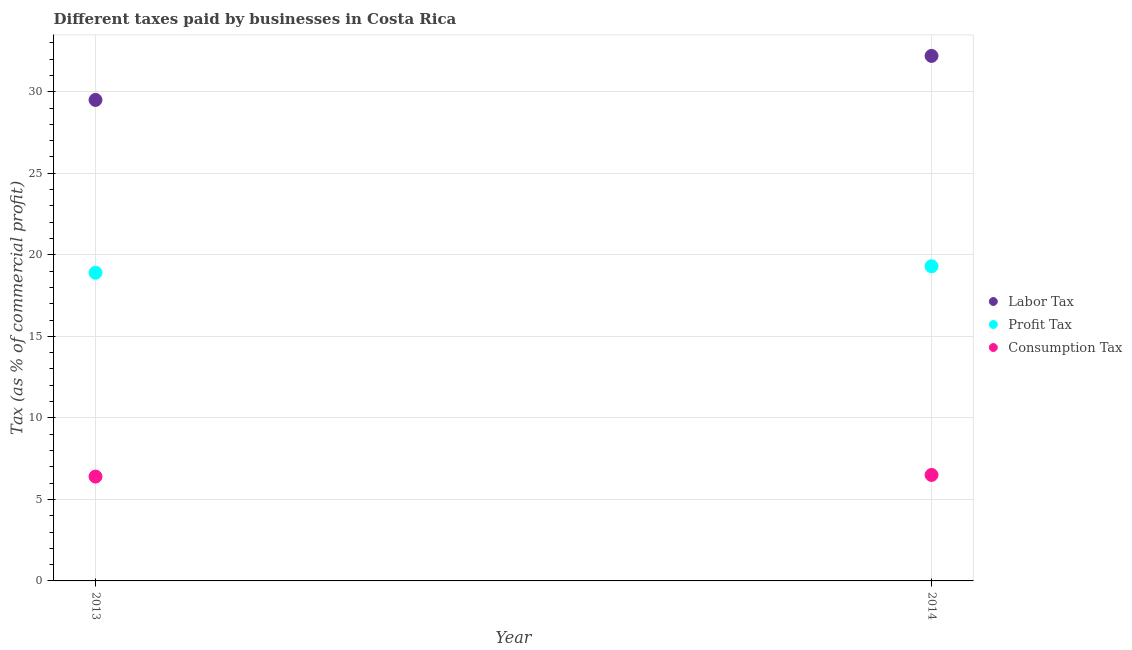How many different coloured dotlines are there?
Provide a short and direct response. 3. Is the number of dotlines equal to the number of legend labels?
Give a very brief answer. Yes. What is the percentage of consumption tax in 2013?
Keep it short and to the point. 6.4. Across all years, what is the maximum percentage of consumption tax?
Your answer should be very brief. 6.5. Across all years, what is the minimum percentage of labor tax?
Offer a terse response. 29.5. In which year was the percentage of consumption tax maximum?
Offer a terse response. 2014. In which year was the percentage of labor tax minimum?
Your response must be concise. 2013. What is the total percentage of consumption tax in the graph?
Make the answer very short. 12.9. What is the difference between the percentage of consumption tax in 2013 and that in 2014?
Provide a succinct answer. -0.1. What is the difference between the percentage of labor tax in 2014 and the percentage of consumption tax in 2013?
Provide a succinct answer. 25.8. What is the average percentage of labor tax per year?
Keep it short and to the point. 30.85. In the year 2013, what is the difference between the percentage of profit tax and percentage of labor tax?
Ensure brevity in your answer.  -10.6. In how many years, is the percentage of labor tax greater than 30 %?
Provide a succinct answer. 1. What is the ratio of the percentage of labor tax in 2013 to that in 2014?
Keep it short and to the point. 0.92. Is the percentage of consumption tax in 2013 less than that in 2014?
Your response must be concise. Yes. In how many years, is the percentage of consumption tax greater than the average percentage of consumption tax taken over all years?
Provide a short and direct response. 1. Is the percentage of consumption tax strictly greater than the percentage of profit tax over the years?
Your answer should be compact. No. Is the percentage of labor tax strictly less than the percentage of consumption tax over the years?
Provide a short and direct response. No. What is the difference between two consecutive major ticks on the Y-axis?
Keep it short and to the point. 5. Are the values on the major ticks of Y-axis written in scientific E-notation?
Offer a very short reply. No. Does the graph contain grids?
Offer a terse response. Yes. How many legend labels are there?
Make the answer very short. 3. How are the legend labels stacked?
Provide a succinct answer. Vertical. What is the title of the graph?
Offer a very short reply. Different taxes paid by businesses in Costa Rica. What is the label or title of the X-axis?
Offer a very short reply. Year. What is the label or title of the Y-axis?
Your answer should be compact. Tax (as % of commercial profit). What is the Tax (as % of commercial profit) in Labor Tax in 2013?
Your response must be concise. 29.5. What is the Tax (as % of commercial profit) of Labor Tax in 2014?
Provide a short and direct response. 32.2. What is the Tax (as % of commercial profit) of Profit Tax in 2014?
Offer a terse response. 19.3. Across all years, what is the maximum Tax (as % of commercial profit) of Labor Tax?
Offer a very short reply. 32.2. Across all years, what is the maximum Tax (as % of commercial profit) of Profit Tax?
Provide a short and direct response. 19.3. Across all years, what is the maximum Tax (as % of commercial profit) in Consumption Tax?
Provide a succinct answer. 6.5. Across all years, what is the minimum Tax (as % of commercial profit) in Labor Tax?
Offer a terse response. 29.5. Across all years, what is the minimum Tax (as % of commercial profit) in Profit Tax?
Make the answer very short. 18.9. What is the total Tax (as % of commercial profit) in Labor Tax in the graph?
Keep it short and to the point. 61.7. What is the total Tax (as % of commercial profit) of Profit Tax in the graph?
Provide a short and direct response. 38.2. What is the total Tax (as % of commercial profit) of Consumption Tax in the graph?
Your answer should be compact. 12.9. What is the difference between the Tax (as % of commercial profit) of Consumption Tax in 2013 and that in 2014?
Keep it short and to the point. -0.1. What is the difference between the Tax (as % of commercial profit) in Labor Tax in 2013 and the Tax (as % of commercial profit) in Consumption Tax in 2014?
Keep it short and to the point. 23. What is the difference between the Tax (as % of commercial profit) in Profit Tax in 2013 and the Tax (as % of commercial profit) in Consumption Tax in 2014?
Provide a succinct answer. 12.4. What is the average Tax (as % of commercial profit) of Labor Tax per year?
Give a very brief answer. 30.85. What is the average Tax (as % of commercial profit) in Consumption Tax per year?
Your answer should be compact. 6.45. In the year 2013, what is the difference between the Tax (as % of commercial profit) of Labor Tax and Tax (as % of commercial profit) of Consumption Tax?
Make the answer very short. 23.1. In the year 2013, what is the difference between the Tax (as % of commercial profit) in Profit Tax and Tax (as % of commercial profit) in Consumption Tax?
Your answer should be very brief. 12.5. In the year 2014, what is the difference between the Tax (as % of commercial profit) of Labor Tax and Tax (as % of commercial profit) of Profit Tax?
Offer a terse response. 12.9. In the year 2014, what is the difference between the Tax (as % of commercial profit) in Labor Tax and Tax (as % of commercial profit) in Consumption Tax?
Offer a terse response. 25.7. What is the ratio of the Tax (as % of commercial profit) of Labor Tax in 2013 to that in 2014?
Your answer should be very brief. 0.92. What is the ratio of the Tax (as % of commercial profit) in Profit Tax in 2013 to that in 2014?
Your answer should be compact. 0.98. What is the ratio of the Tax (as % of commercial profit) in Consumption Tax in 2013 to that in 2014?
Provide a short and direct response. 0.98. What is the difference between the highest and the second highest Tax (as % of commercial profit) of Profit Tax?
Provide a short and direct response. 0.4. What is the difference between the highest and the second highest Tax (as % of commercial profit) of Consumption Tax?
Keep it short and to the point. 0.1. What is the difference between the highest and the lowest Tax (as % of commercial profit) in Profit Tax?
Give a very brief answer. 0.4. What is the difference between the highest and the lowest Tax (as % of commercial profit) in Consumption Tax?
Ensure brevity in your answer.  0.1. 